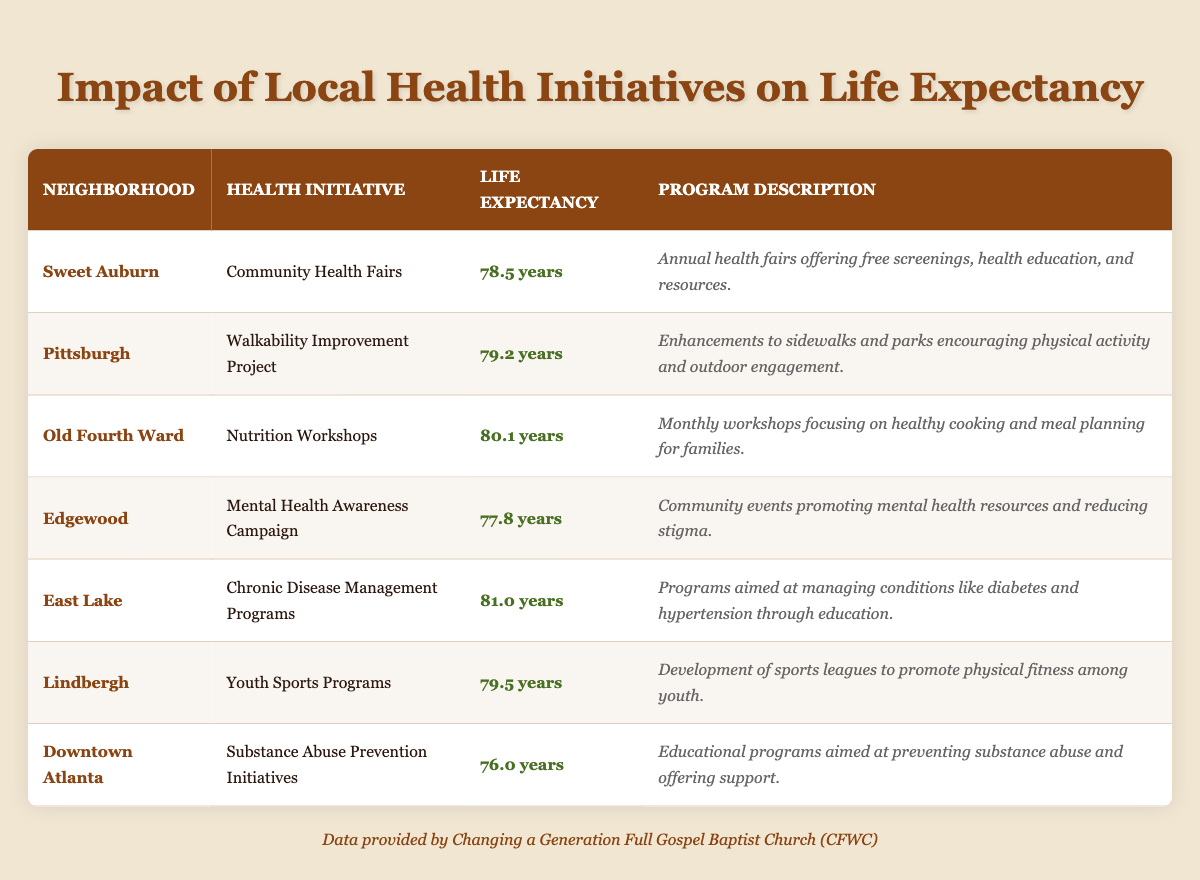What is the life expectancy in the East Lake neighborhood? The life expectancy listed in the East Lake neighborhood is found in that row of the table, specifically under the "Life Expectancy" column, which states 81.0 years.
Answer: 81.0 years Which health initiative in the Old Fourth Ward has the highest life expectancy? The life expectancy for the Old Fourth Ward is 80.1 years, which is the highest among the initiatives listed when compared to the other neighborhoods.
Answer: Nutrition Workshops Is the life expectancy in Edgewood higher than in Sweet Auburn? Edgewood has a life expectancy of 77.8 years, while Sweet Auburn has a life expectancy of 78.5 years. Since 78.5 is greater than 77.8, the statement is false.
Answer: No What is the average life expectancy of the neighborhoods listed? To find the average, add the life expectancies: (78.5 + 79.2 + 80.1 + 77.8 + 81.0 + 79.5 + 76.0) = 452.1. There are 7 neighborhoods, so divide 452.1 by 7, which equals approximately 64.0 years.
Answer: Approximately 64.0 years Which neighborhood has the lowest life expectancy, and what is the value? In the table, Downtown Atlanta has the lowest life expectancy at 76.0 years, as seen in the respective row of the table.
Answer: Downtown Atlanta, 76.0 years Are there more neighborhoods with life expectancies above 79 years compared to those below it? The counts of neighborhoods with life expectancies above 79 years are East Lake (81.0), Old Fourth Ward (80.1), and Pittsburgh (79.2), totaling 3. The neighborhoods below 79 years are Sweet Auburn (78.5), Edgewood (77.8), and Downtown Atlanta (76.0), totaling 3 as well. Since both categories have the same number, the answer is equal.
Answer: No If we combine the life expectancy of Sweet Auburn and Edgewood, what is the total? The life expectancy of Sweet Auburn is 78.5 years, and Edgewood is 77.8 years. Adding these two values gives us: 78.5 + 77.8 = 156.3 years.
Answer: 156.3 years What program in Downtown Atlanta focuses on mental health? The program listed for Downtown Atlanta is the Substance Abuse Prevention Initiatives, which focuses on preventing substance abuse rather than mental health. No program specifically pertains to mental health in this neighborhood.
Answer: No program focuses on mental health in Downtown Atlanta 